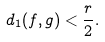<formula> <loc_0><loc_0><loc_500><loc_500>d _ { 1 } ( f , g ) < \frac { r } { 2 } .</formula> 